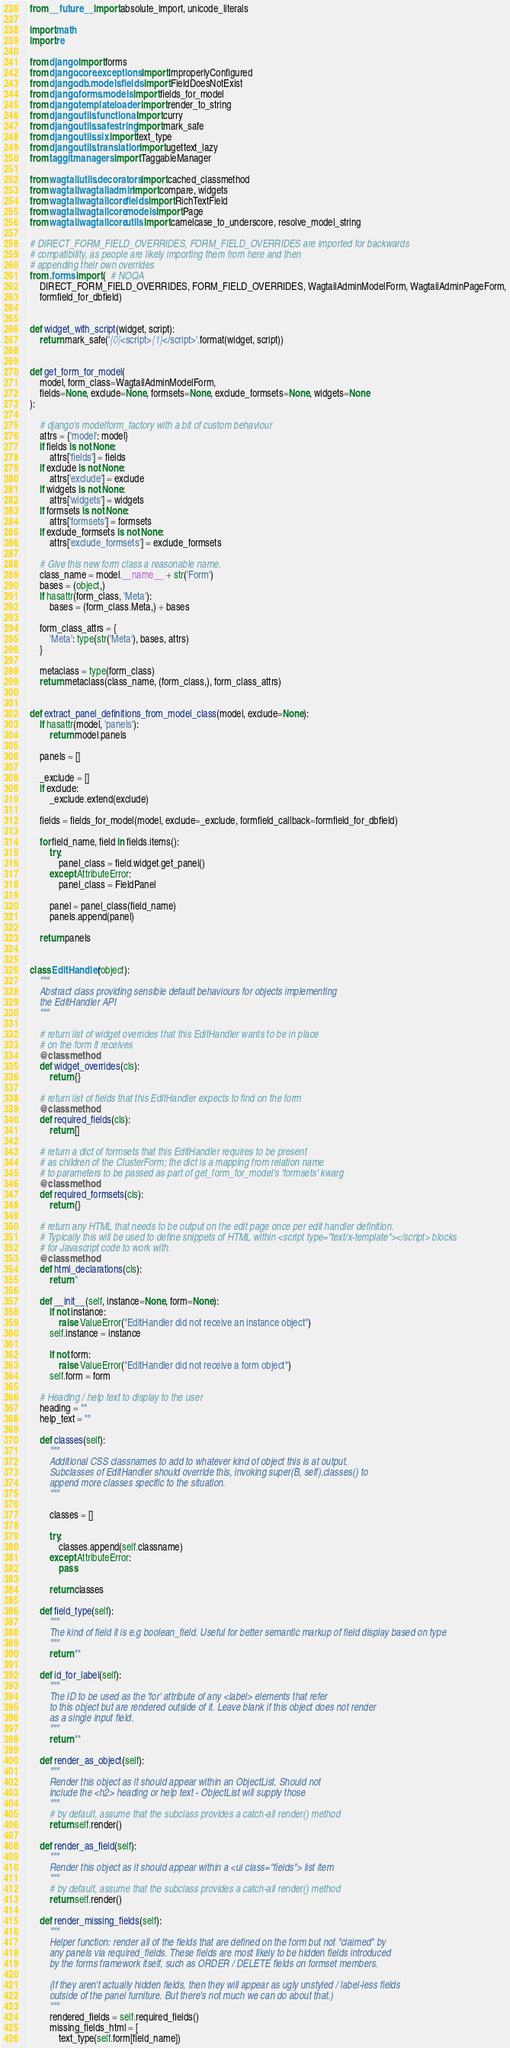<code> <loc_0><loc_0><loc_500><loc_500><_Python_>from __future__ import absolute_import, unicode_literals

import math
import re

from django import forms
from django.core.exceptions import ImproperlyConfigured
from django.db.models.fields import FieldDoesNotExist
from django.forms.models import fields_for_model
from django.template.loader import render_to_string
from django.utils.functional import curry
from django.utils.safestring import mark_safe
from django.utils.six import text_type
from django.utils.translation import ugettext_lazy
from taggit.managers import TaggableManager

from wagtail.utils.decorators import cached_classmethod
from wagtail.wagtailadmin import compare, widgets
from wagtail.wagtailcore.fields import RichTextField
from wagtail.wagtailcore.models import Page
from wagtail.wagtailcore.utils import camelcase_to_underscore, resolve_model_string

# DIRECT_FORM_FIELD_OVERRIDES, FORM_FIELD_OVERRIDES are imported for backwards
# compatibility, as people are likely importing them from here and then
# appending their own overrides
from .forms import (  # NOQA
    DIRECT_FORM_FIELD_OVERRIDES, FORM_FIELD_OVERRIDES, WagtailAdminModelForm, WagtailAdminPageForm,
    formfield_for_dbfield)


def widget_with_script(widget, script):
    return mark_safe('{0}<script>{1}</script>'.format(widget, script))


def get_form_for_model(
    model, form_class=WagtailAdminModelForm,
    fields=None, exclude=None, formsets=None, exclude_formsets=None, widgets=None
):

    # django's modelform_factory with a bit of custom behaviour
    attrs = {'model': model}
    if fields is not None:
        attrs['fields'] = fields
    if exclude is not None:
        attrs['exclude'] = exclude
    if widgets is not None:
        attrs['widgets'] = widgets
    if formsets is not None:
        attrs['formsets'] = formsets
    if exclude_formsets is not None:
        attrs['exclude_formsets'] = exclude_formsets

    # Give this new form class a reasonable name.
    class_name = model.__name__ + str('Form')
    bases = (object,)
    if hasattr(form_class, 'Meta'):
        bases = (form_class.Meta,) + bases

    form_class_attrs = {
        'Meta': type(str('Meta'), bases, attrs)
    }

    metaclass = type(form_class)
    return metaclass(class_name, (form_class,), form_class_attrs)


def extract_panel_definitions_from_model_class(model, exclude=None):
    if hasattr(model, 'panels'):
        return model.panels

    panels = []

    _exclude = []
    if exclude:
        _exclude.extend(exclude)

    fields = fields_for_model(model, exclude=_exclude, formfield_callback=formfield_for_dbfield)

    for field_name, field in fields.items():
        try:
            panel_class = field.widget.get_panel()
        except AttributeError:
            panel_class = FieldPanel

        panel = panel_class(field_name)
        panels.append(panel)

    return panels


class EditHandler(object):
    """
    Abstract class providing sensible default behaviours for objects implementing
    the EditHandler API
    """

    # return list of widget overrides that this EditHandler wants to be in place
    # on the form it receives
    @classmethod
    def widget_overrides(cls):
        return {}

    # return list of fields that this EditHandler expects to find on the form
    @classmethod
    def required_fields(cls):
        return []

    # return a dict of formsets that this EditHandler requires to be present
    # as children of the ClusterForm; the dict is a mapping from relation name
    # to parameters to be passed as part of get_form_for_model's 'formsets' kwarg
    @classmethod
    def required_formsets(cls):
        return {}

    # return any HTML that needs to be output on the edit page once per edit handler definition.
    # Typically this will be used to define snippets of HTML within <script type="text/x-template"></script> blocks
    # for Javascript code to work with.
    @classmethod
    def html_declarations(cls):
        return ''

    def __init__(self, instance=None, form=None):
        if not instance:
            raise ValueError("EditHandler did not receive an instance object")
        self.instance = instance

        if not form:
            raise ValueError("EditHandler did not receive a form object")
        self.form = form

    # Heading / help text to display to the user
    heading = ""
    help_text = ""

    def classes(self):
        """
        Additional CSS classnames to add to whatever kind of object this is at output.
        Subclasses of EditHandler should override this, invoking super(B, self).classes() to
        append more classes specific to the situation.
        """

        classes = []

        try:
            classes.append(self.classname)
        except AttributeError:
            pass

        return classes

    def field_type(self):
        """
        The kind of field it is e.g boolean_field. Useful for better semantic markup of field display based on type
        """
        return ""

    def id_for_label(self):
        """
        The ID to be used as the 'for' attribute of any <label> elements that refer
        to this object but are rendered outside of it. Leave blank if this object does not render
        as a single input field.
        """
        return ""

    def render_as_object(self):
        """
        Render this object as it should appear within an ObjectList. Should not
        include the <h2> heading or help text - ObjectList will supply those
        """
        # by default, assume that the subclass provides a catch-all render() method
        return self.render()

    def render_as_field(self):
        """
        Render this object as it should appear within a <ul class="fields"> list item
        """
        # by default, assume that the subclass provides a catch-all render() method
        return self.render()

    def render_missing_fields(self):
        """
        Helper function: render all of the fields that are defined on the form but not "claimed" by
        any panels via required_fields. These fields are most likely to be hidden fields introduced
        by the forms framework itself, such as ORDER / DELETE fields on formset members.

        (If they aren't actually hidden fields, then they will appear as ugly unstyled / label-less fields
        outside of the panel furniture. But there's not much we can do about that.)
        """
        rendered_fields = self.required_fields()
        missing_fields_html = [
            text_type(self.form[field_name])</code> 